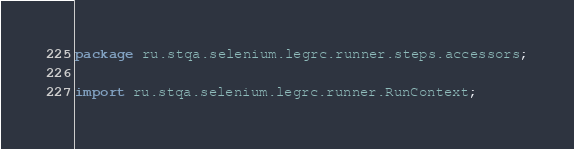<code> <loc_0><loc_0><loc_500><loc_500><_Java_>package ru.stqa.selenium.legrc.runner.steps.accessors;

import ru.stqa.selenium.legrc.runner.RunContext;</code> 